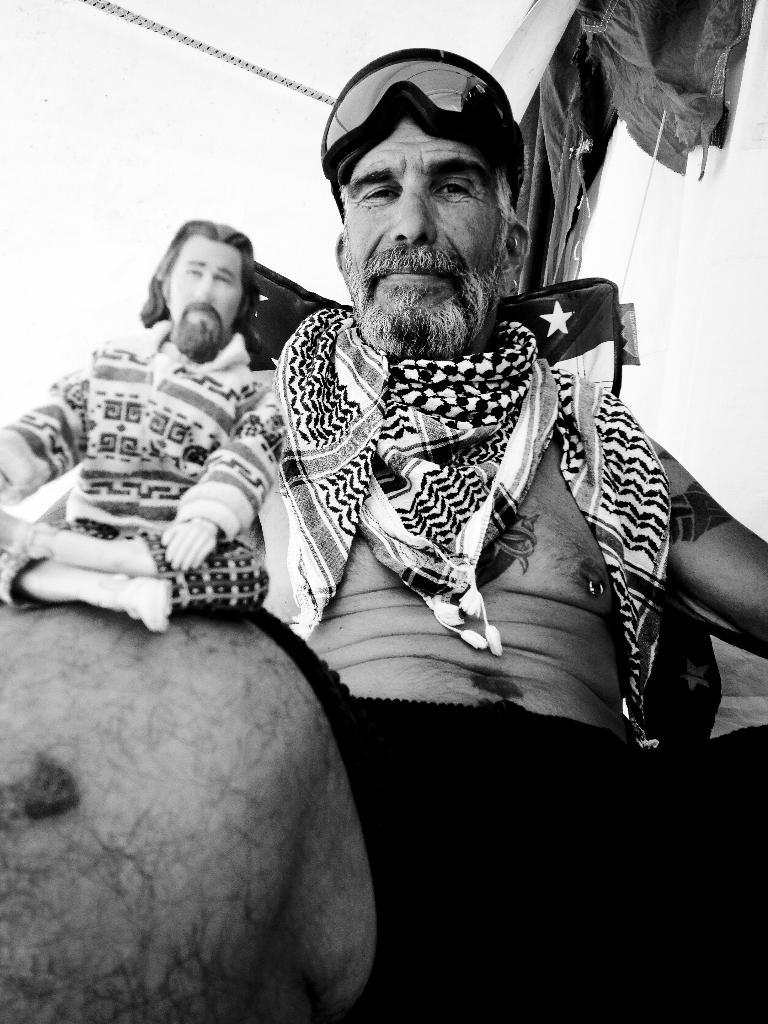What is the color scheme of the image? The image is black and white. How many people are present in the image? There are two persons sitting in the image. What is one person wearing in the image? One person is wearing a scarf. What is the other person wearing in the image? The other person is wearing a t-shirt. How many rabbits can be seen in the image? There are no rabbits present in the image. What type of selection process is being conducted in the image? There is no selection process depicted in the image. 